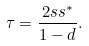Convert formula to latex. <formula><loc_0><loc_0><loc_500><loc_500>\tau = \frac { 2 s s ^ { * } } { 1 - d } .</formula> 